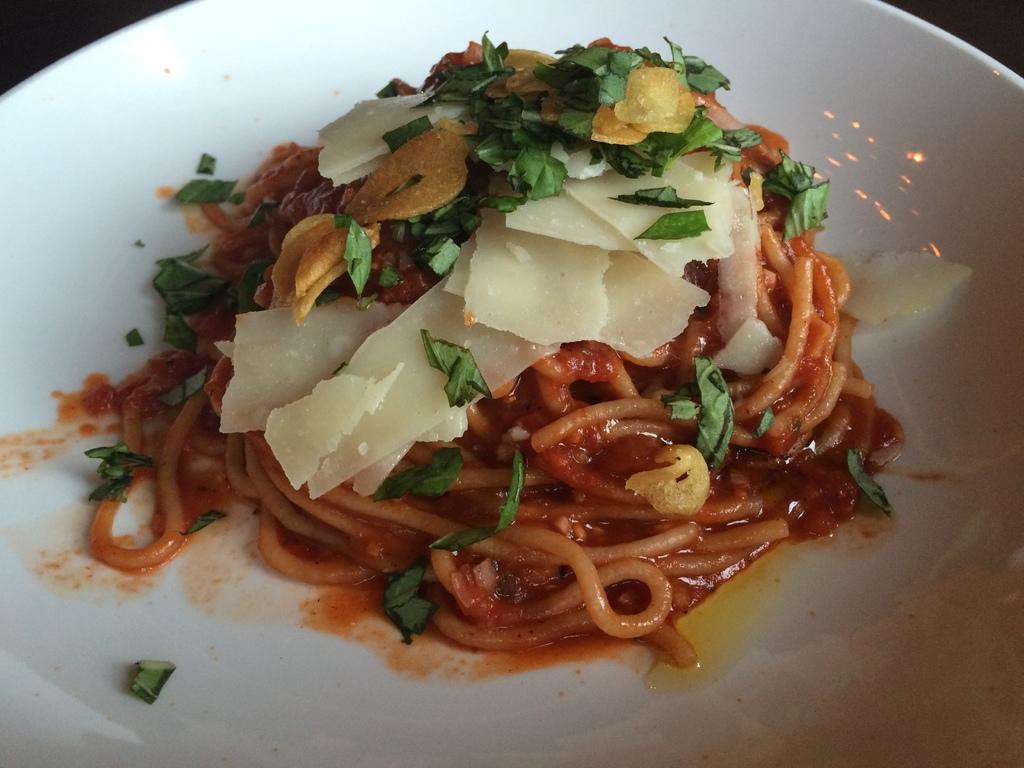In one or two sentences, can you explain what this image depicts? In this picture we can see food in the plate. 